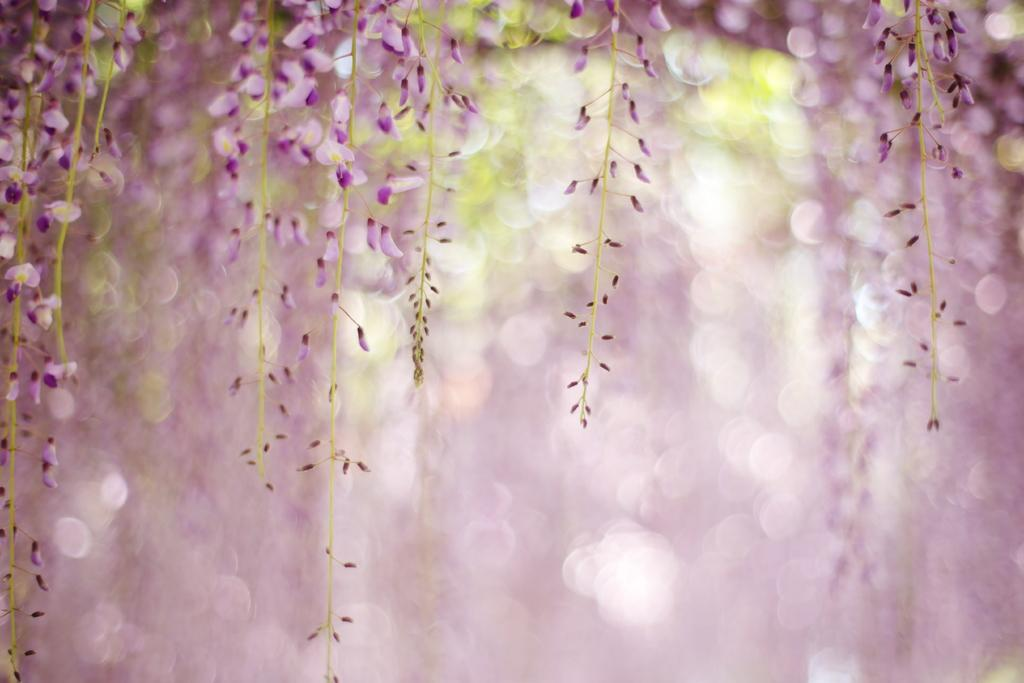What type of vegetation can be seen on the trees in the image? There are flowers on the trees in the image. What colors are the flowers? The flowers are pink and green in color. Can you describe the background of the image? The background of the image is blurry. How many toes are visible on the flowers in the image? There are no toes present in the image, as the subject is flowers on trees. 